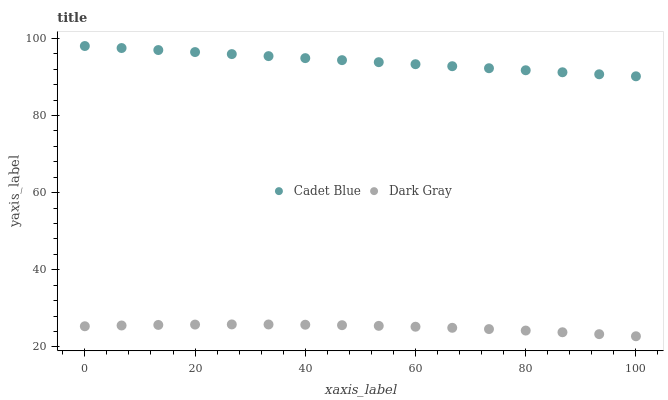Does Dark Gray have the minimum area under the curve?
Answer yes or no. Yes. Does Cadet Blue have the maximum area under the curve?
Answer yes or no. Yes. Does Cadet Blue have the minimum area under the curve?
Answer yes or no. No. Is Cadet Blue the smoothest?
Answer yes or no. Yes. Is Dark Gray the roughest?
Answer yes or no. Yes. Is Cadet Blue the roughest?
Answer yes or no. No. Does Dark Gray have the lowest value?
Answer yes or no. Yes. Does Cadet Blue have the lowest value?
Answer yes or no. No. Does Cadet Blue have the highest value?
Answer yes or no. Yes. Is Dark Gray less than Cadet Blue?
Answer yes or no. Yes. Is Cadet Blue greater than Dark Gray?
Answer yes or no. Yes. Does Dark Gray intersect Cadet Blue?
Answer yes or no. No. 